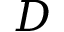Convert formula to latex. <formula><loc_0><loc_0><loc_500><loc_500>D</formula> 